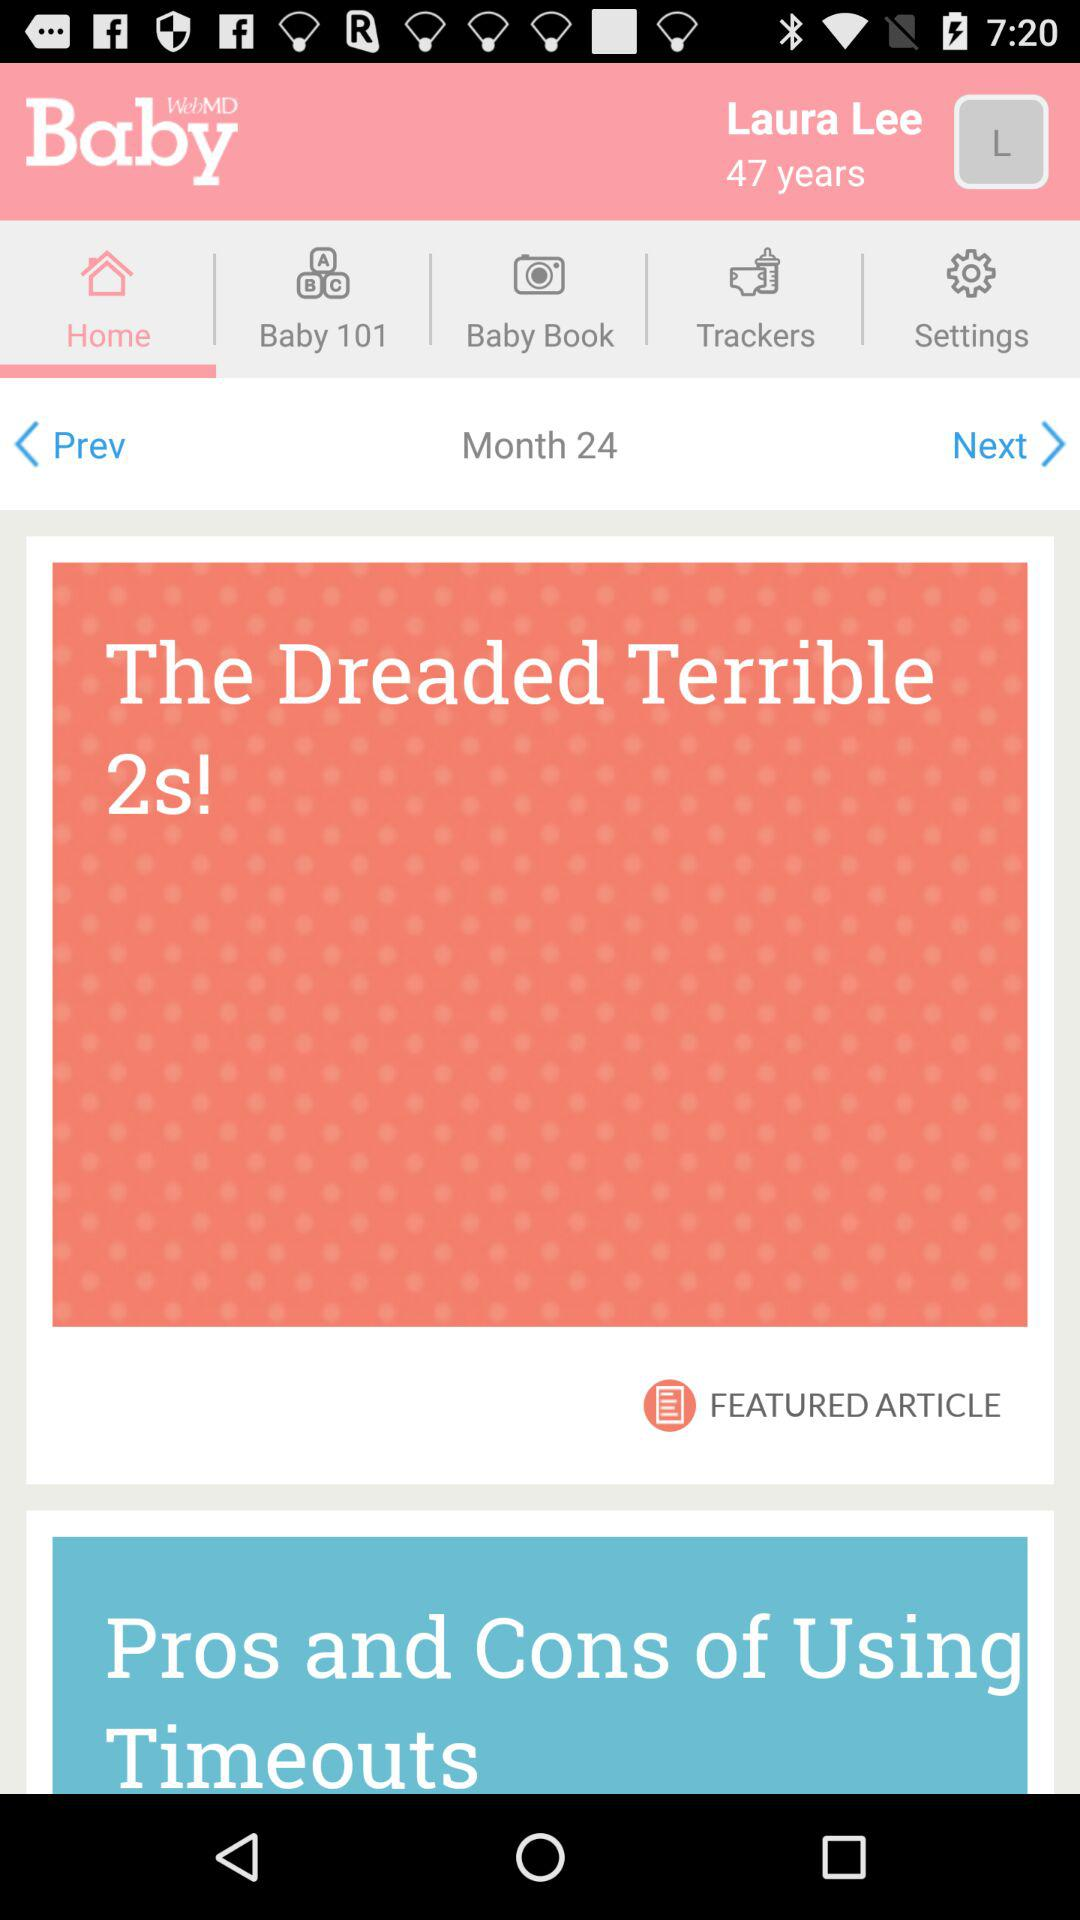What month is this? This is month 24. 